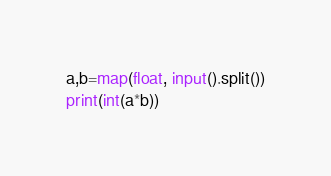Convert code to text. <code><loc_0><loc_0><loc_500><loc_500><_Python_>a,b=map(float, input().split())
print(int(a*b))</code> 